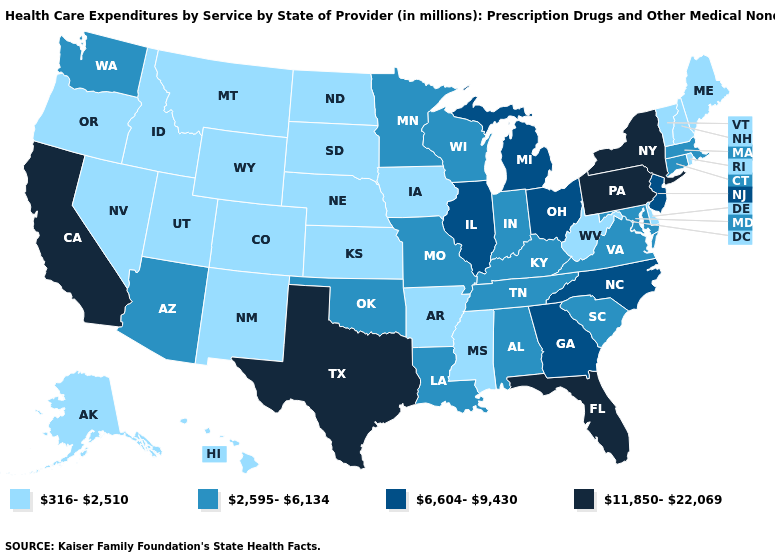What is the value of South Carolina?
Write a very short answer. 2,595-6,134. What is the value of New Mexico?
Short answer required. 316-2,510. Does the map have missing data?
Write a very short answer. No. What is the value of South Dakota?
Be succinct. 316-2,510. Name the states that have a value in the range 2,595-6,134?
Keep it brief. Alabama, Arizona, Connecticut, Indiana, Kentucky, Louisiana, Maryland, Massachusetts, Minnesota, Missouri, Oklahoma, South Carolina, Tennessee, Virginia, Washington, Wisconsin. Does Nevada have the highest value in the West?
Quick response, please. No. Name the states that have a value in the range 11,850-22,069?
Quick response, please. California, Florida, New York, Pennsylvania, Texas. Which states have the lowest value in the USA?
Keep it brief. Alaska, Arkansas, Colorado, Delaware, Hawaii, Idaho, Iowa, Kansas, Maine, Mississippi, Montana, Nebraska, Nevada, New Hampshire, New Mexico, North Dakota, Oregon, Rhode Island, South Dakota, Utah, Vermont, West Virginia, Wyoming. Which states have the highest value in the USA?
Quick response, please. California, Florida, New York, Pennsylvania, Texas. Name the states that have a value in the range 316-2,510?
Write a very short answer. Alaska, Arkansas, Colorado, Delaware, Hawaii, Idaho, Iowa, Kansas, Maine, Mississippi, Montana, Nebraska, Nevada, New Hampshire, New Mexico, North Dakota, Oregon, Rhode Island, South Dakota, Utah, Vermont, West Virginia, Wyoming. What is the value of Maryland?
Write a very short answer. 2,595-6,134. What is the value of Pennsylvania?
Give a very brief answer. 11,850-22,069. Does Michigan have the lowest value in the USA?
Answer briefly. No. Among the states that border Louisiana , does Texas have the lowest value?
Keep it brief. No. 